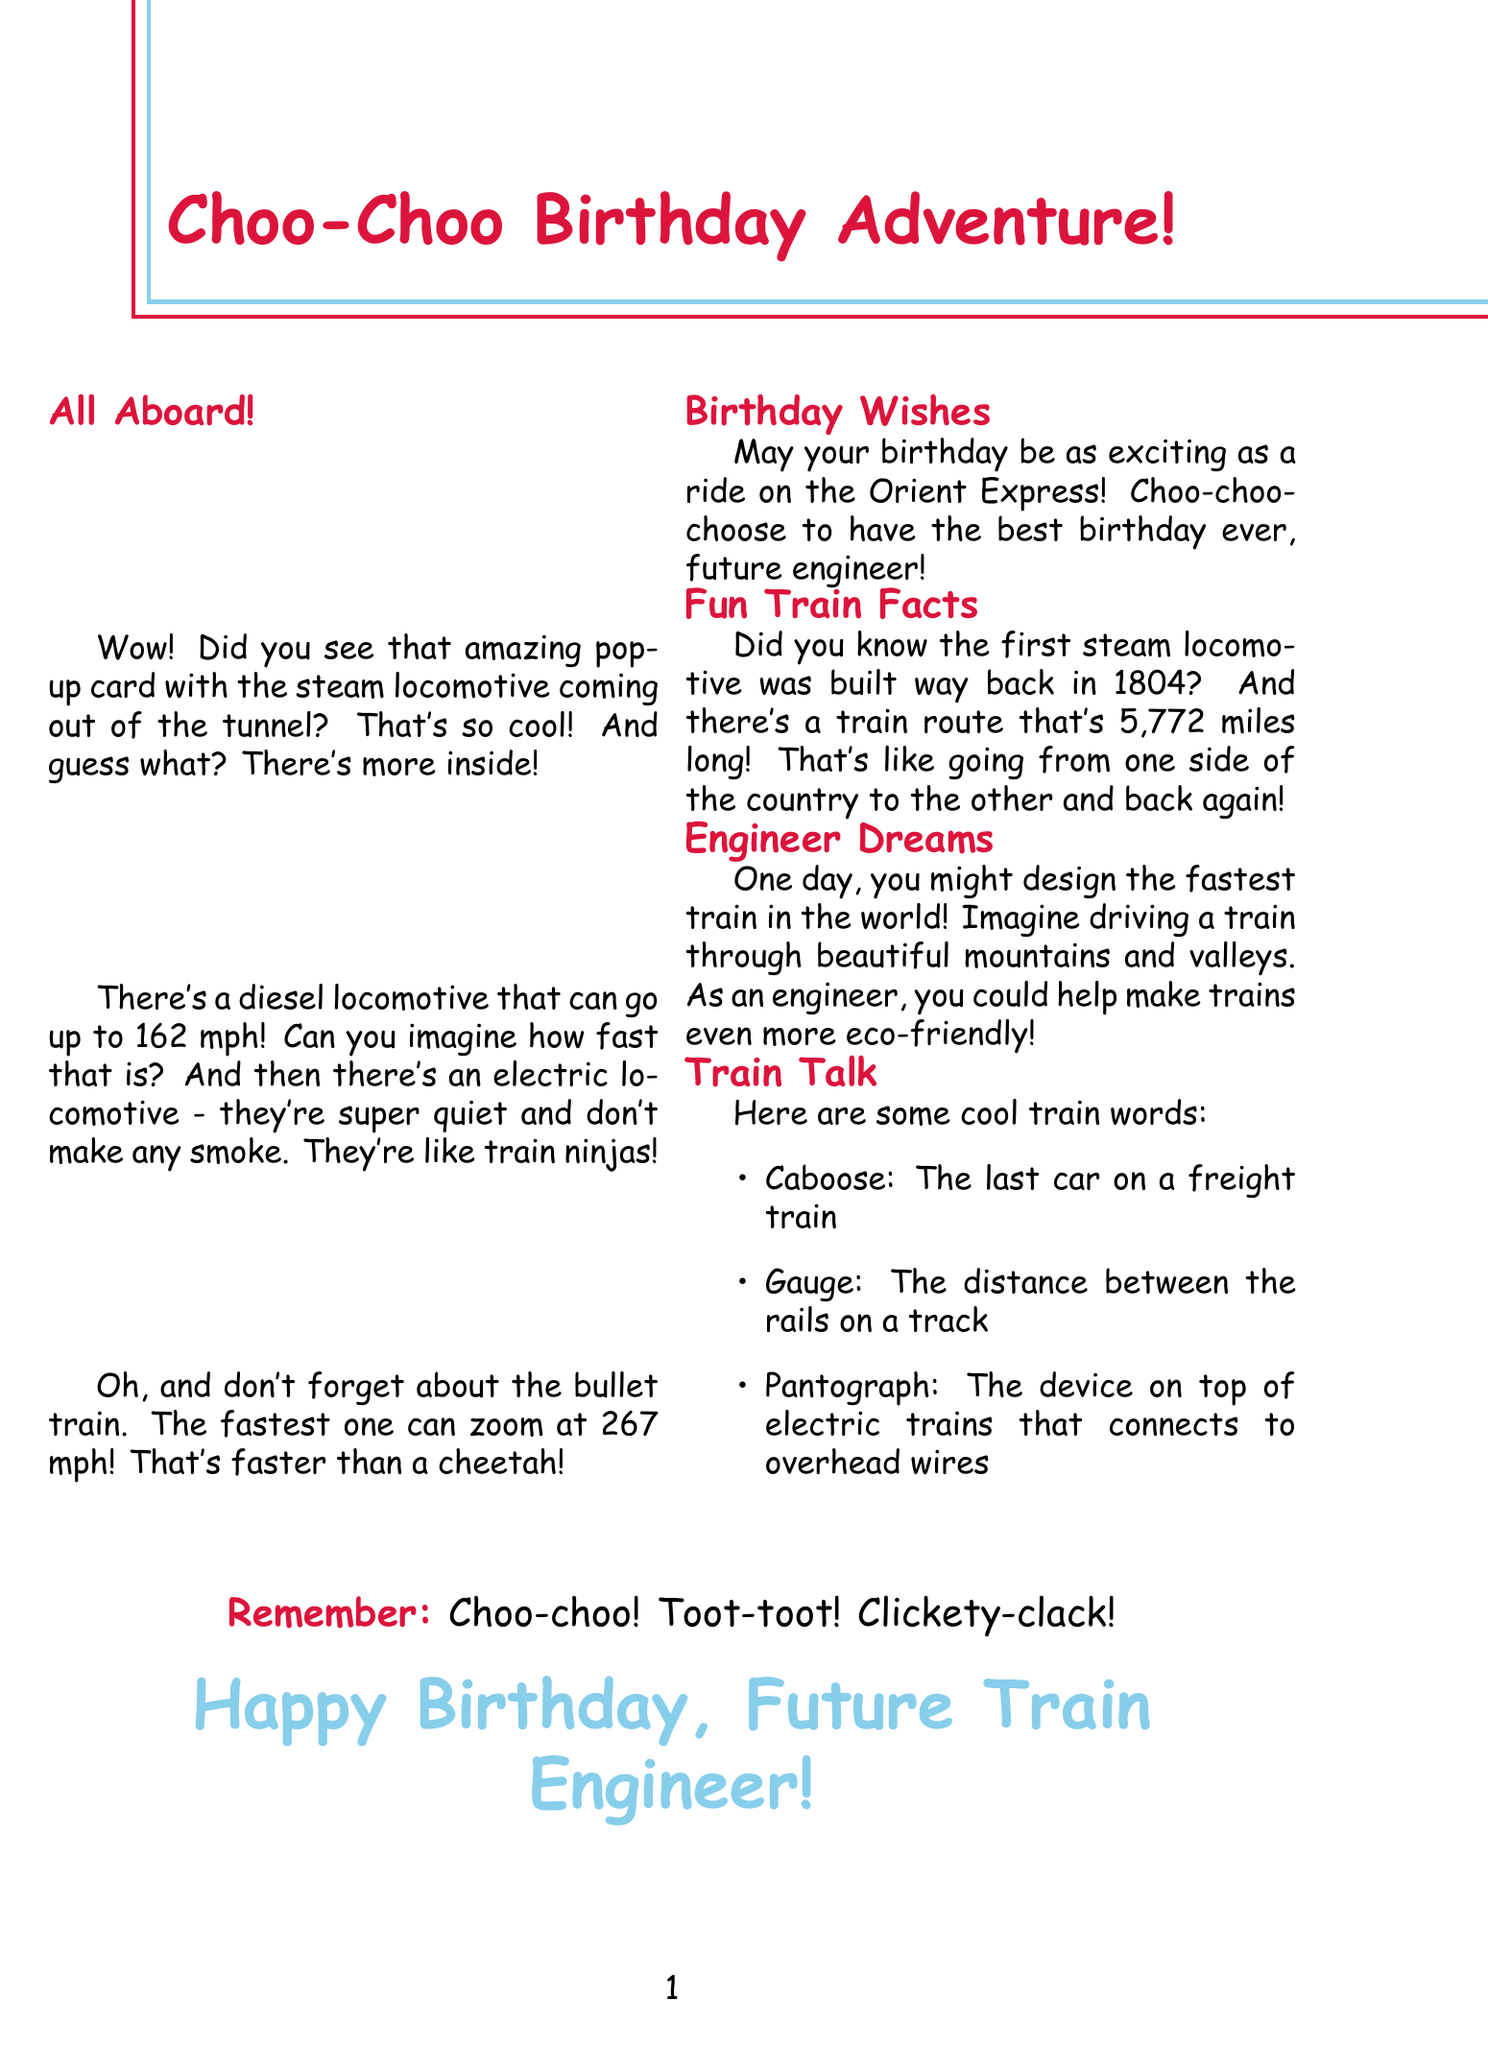What type of locomotive is featured on the card cover? The card cover features a steam locomotive.
Answer: steam locomotive What is the fastest speed of the SNCF CC 72000? This diesel locomotive can reach speeds up to 162 mph.
Answer: 162 mph What unique feature do electric locomotives have? Electric locomotives are described as super quiet and don't produce any smoke.
Answer: super quiet What is the speed of the fastest bullet train? The fastest bullet train can zoom at an incredible 267 mph.
Answer: 267 mph Who built the first steam locomotive? The first steam locomotive was built by Richard Trevithick.
Answer: Richard Trevithick What does the birthday wish say about the Orient Express? It mentions that the birthday should be as exciting as a ride on the Orient Express!
Answer: as exciting as a ride on the Orient Express What is the smallest locomotive height mentioned? The smallest locomotive ever built was just 24 inches tall.
Answer: 24 inches What can future engineers help make trains? Future engineers could help make trains even more eco-friendly!
Answer: eco-friendly What sound do trains make, as per the card? The card includes fun sounds like "Choo-choo!"
Answer: Choo-choo! 